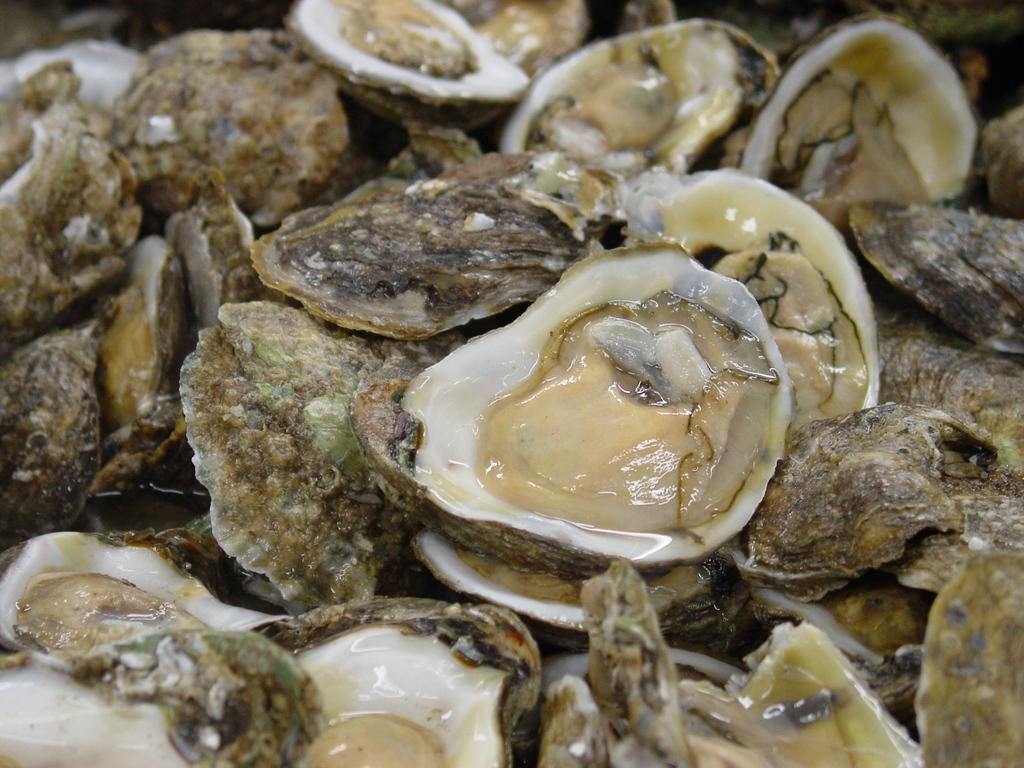What type of objects can be seen in the image? There are shells in the image. Can you describe the colors of the shells? The shells have different colors, including white, brown, and black. What is the cream and white colored object on the shells? Unfortunately, the provided facts do not give enough information to describe the cream and white colored object on the shells. What type of silk is being used to make the family's bean bags in the image? There is no silk, family, or bean bags present in the image. 